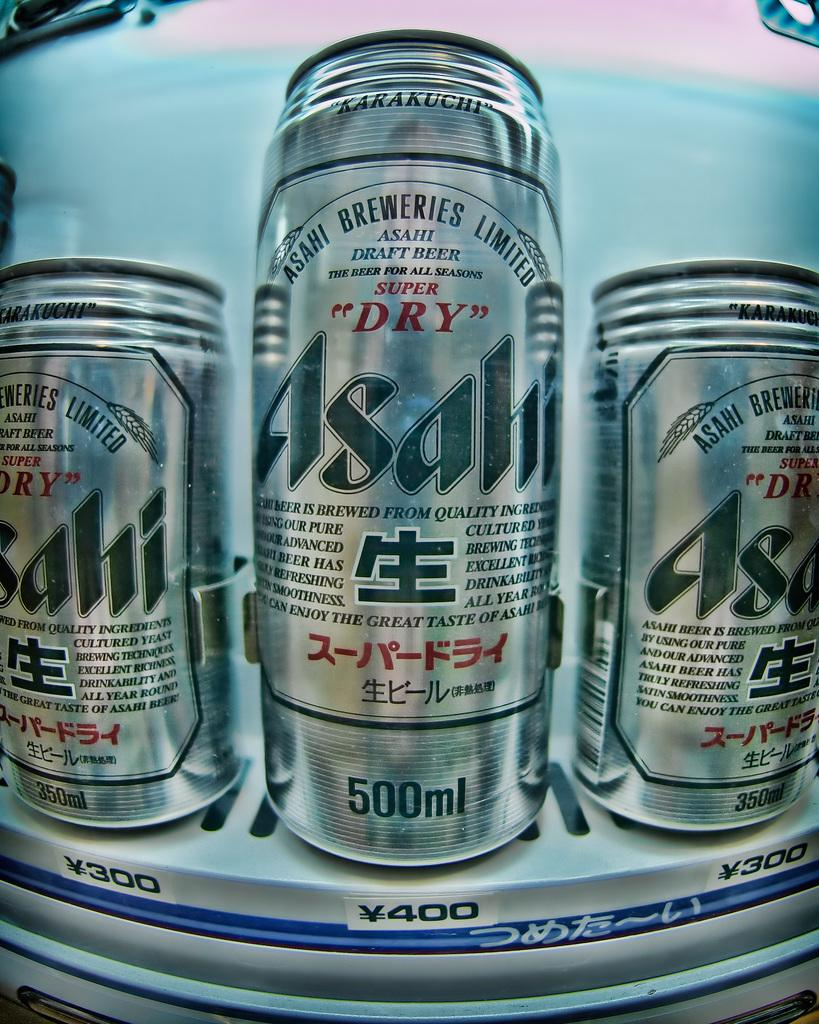<image>
Provide a brief description of the given image. Silver cans are in a line and all have a Asahi logo on them. 